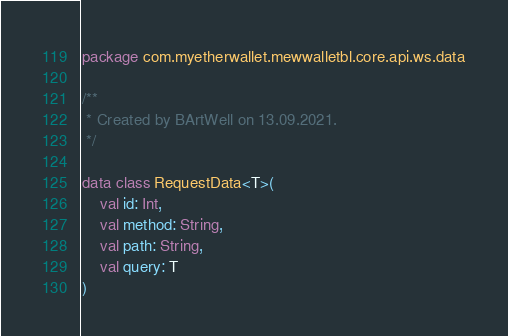Convert code to text. <code><loc_0><loc_0><loc_500><loc_500><_Kotlin_>package com.myetherwallet.mewwalletbl.core.api.ws.data

/**
 * Created by BArtWell on 13.09.2021.
 */

data class RequestData<T>(
    val id: Int,
    val method: String,
    val path: String,
    val query: T
)
</code> 